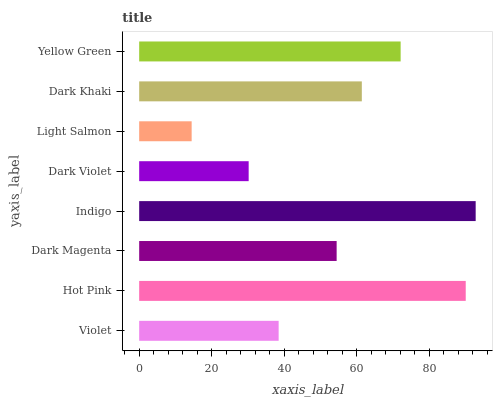Is Light Salmon the minimum?
Answer yes or no. Yes. Is Indigo the maximum?
Answer yes or no. Yes. Is Hot Pink the minimum?
Answer yes or no. No. Is Hot Pink the maximum?
Answer yes or no. No. Is Hot Pink greater than Violet?
Answer yes or no. Yes. Is Violet less than Hot Pink?
Answer yes or no. Yes. Is Violet greater than Hot Pink?
Answer yes or no. No. Is Hot Pink less than Violet?
Answer yes or no. No. Is Dark Khaki the high median?
Answer yes or no. Yes. Is Dark Magenta the low median?
Answer yes or no. Yes. Is Indigo the high median?
Answer yes or no. No. Is Hot Pink the low median?
Answer yes or no. No. 